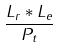<formula> <loc_0><loc_0><loc_500><loc_500>\frac { L _ { r } * L _ { e } } { P _ { t } }</formula> 